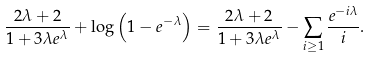Convert formula to latex. <formula><loc_0><loc_0><loc_500><loc_500>\frac { 2 \lambda + 2 } { 1 + 3 \lambda e ^ { \lambda } } + \log \left ( 1 - e ^ { - \lambda } \right ) & = \frac { 2 \lambda + 2 } { 1 + 3 \lambda e ^ { \lambda } } - \sum _ { i \geq 1 } \frac { e ^ { - i \lambda } } { i } .</formula> 